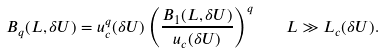Convert formula to latex. <formula><loc_0><loc_0><loc_500><loc_500>B _ { q } ( L , \delta U ) = u _ { c } ^ { q } ( \delta U ) \left ( \frac { B _ { 1 } ( L , \delta U ) } { u _ { c } ( \delta U ) } \right ) ^ { q } \quad L \gg L _ { c } ( \delta U ) .</formula> 